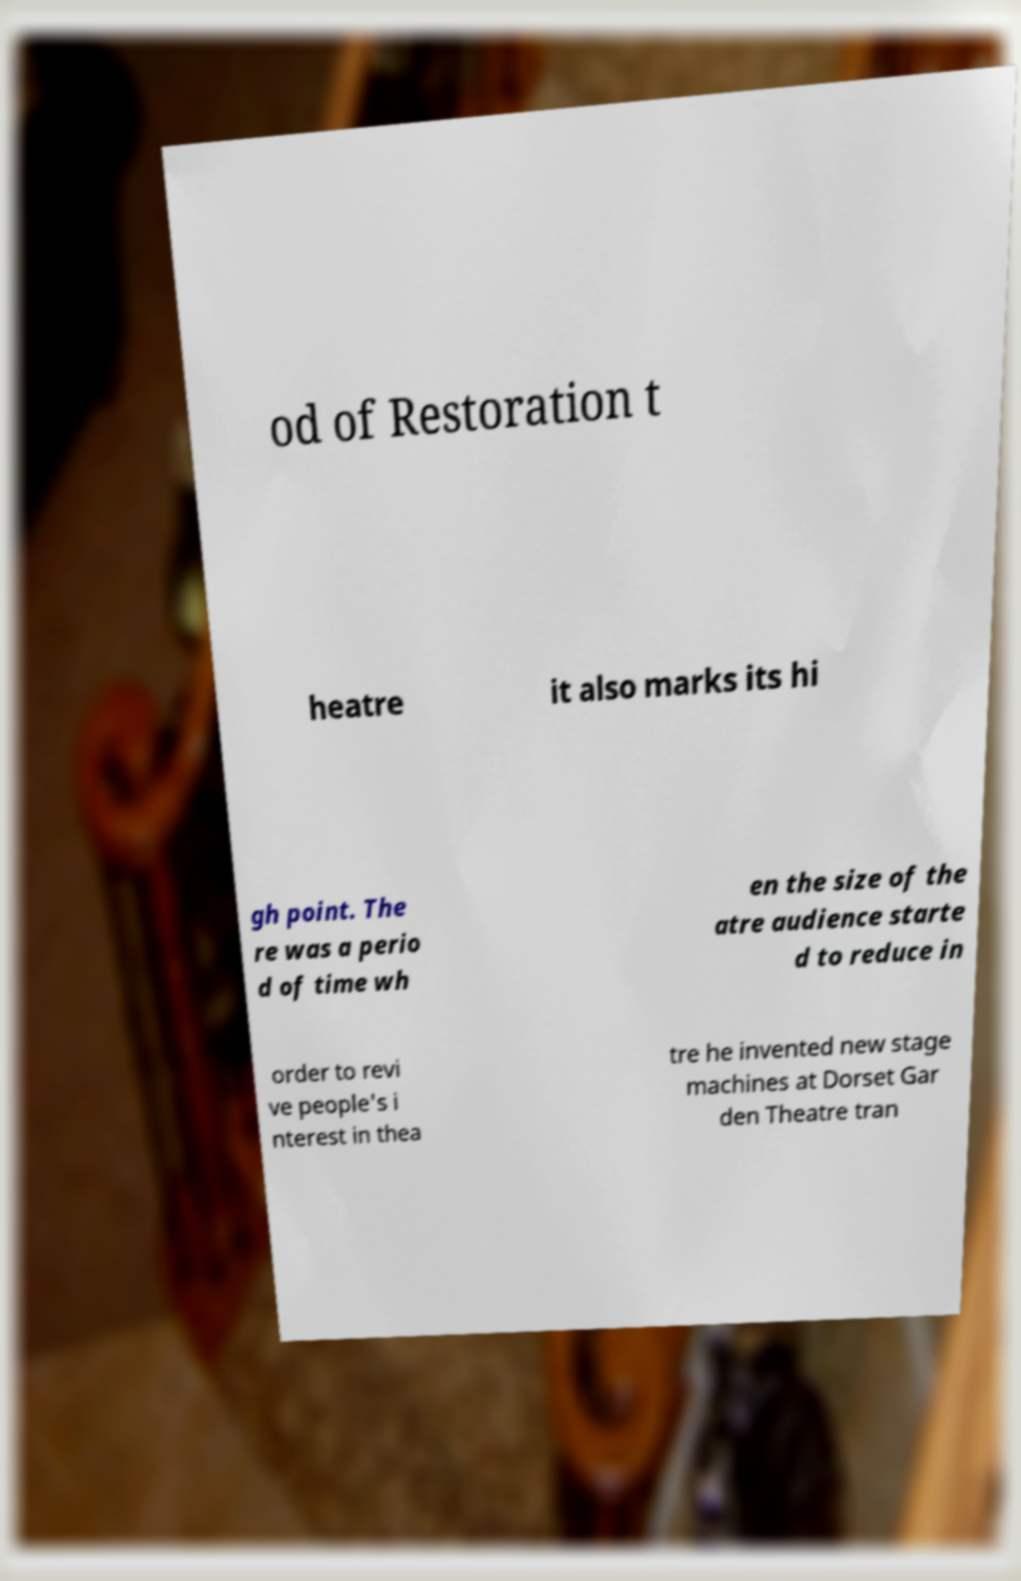Please identify and transcribe the text found in this image. od of Restoration t heatre it also marks its hi gh point. The re was a perio d of time wh en the size of the atre audience starte d to reduce in order to revi ve people's i nterest in thea tre he invented new stage machines at Dorset Gar den Theatre tran 